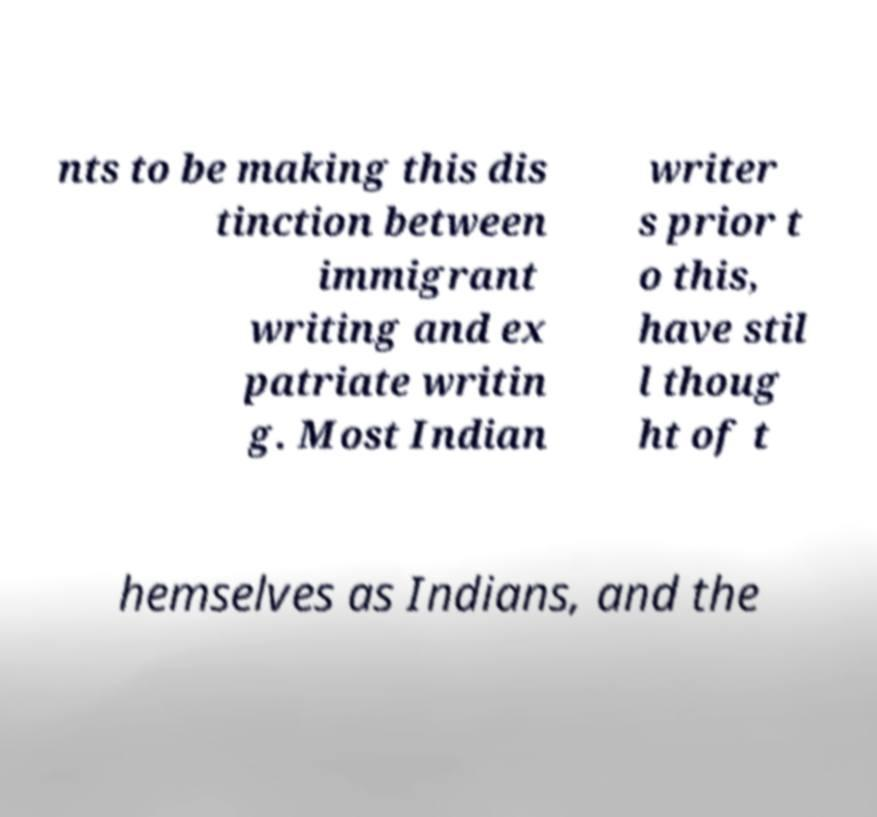There's text embedded in this image that I need extracted. Can you transcribe it verbatim? nts to be making this dis tinction between immigrant writing and ex patriate writin g. Most Indian writer s prior t o this, have stil l thoug ht of t hemselves as Indians, and the 